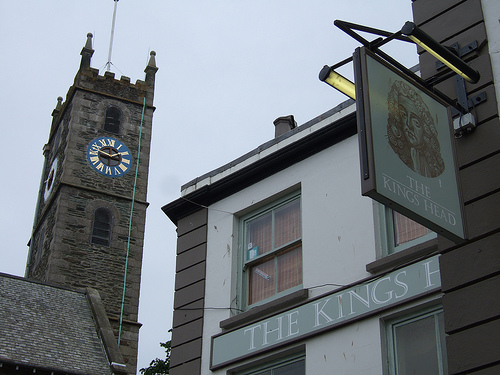Is the white clock on the right side of the photo? No, the white clock is located on the left side above the sign of the King's Head pub. 